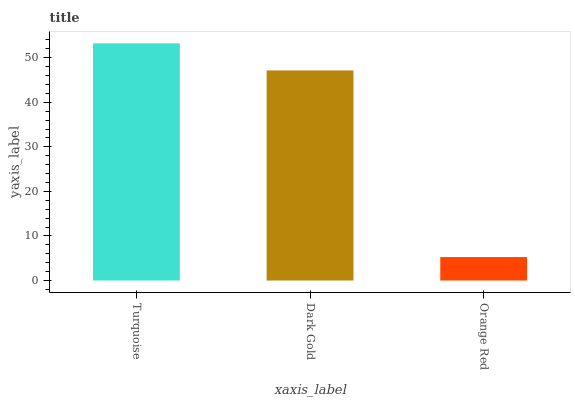Is Orange Red the minimum?
Answer yes or no. Yes. Is Turquoise the maximum?
Answer yes or no. Yes. Is Dark Gold the minimum?
Answer yes or no. No. Is Dark Gold the maximum?
Answer yes or no. No. Is Turquoise greater than Dark Gold?
Answer yes or no. Yes. Is Dark Gold less than Turquoise?
Answer yes or no. Yes. Is Dark Gold greater than Turquoise?
Answer yes or no. No. Is Turquoise less than Dark Gold?
Answer yes or no. No. Is Dark Gold the high median?
Answer yes or no. Yes. Is Dark Gold the low median?
Answer yes or no. Yes. Is Turquoise the high median?
Answer yes or no. No. Is Orange Red the low median?
Answer yes or no. No. 